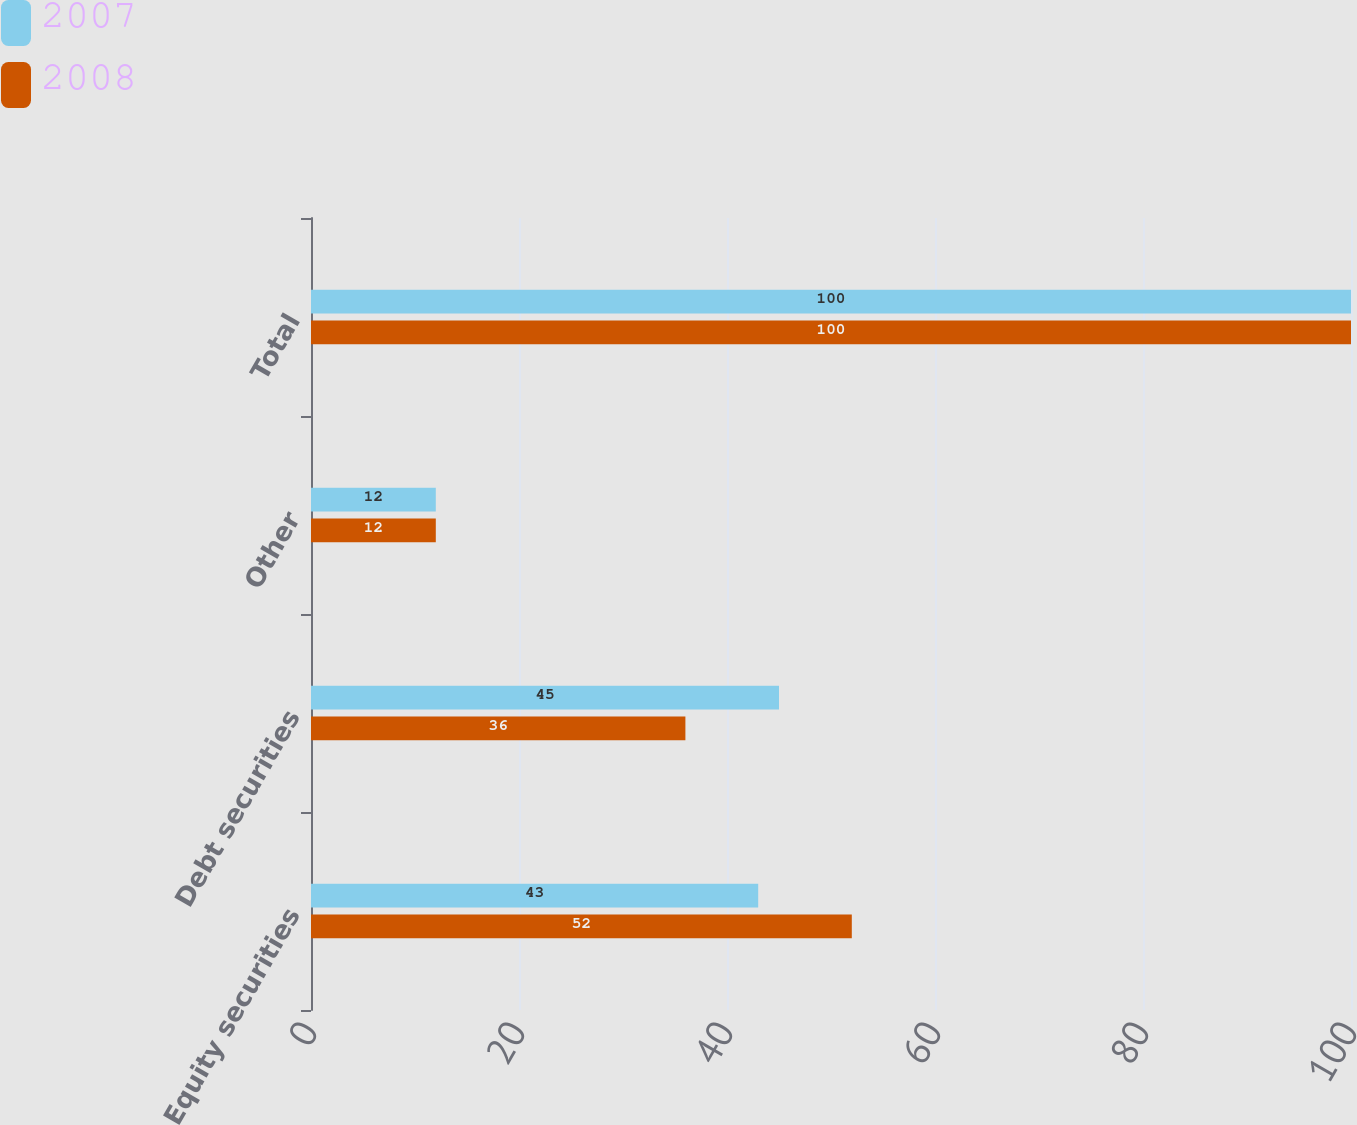<chart> <loc_0><loc_0><loc_500><loc_500><stacked_bar_chart><ecel><fcel>Equity securities<fcel>Debt securities<fcel>Other<fcel>Total<nl><fcel>2007<fcel>43<fcel>45<fcel>12<fcel>100<nl><fcel>2008<fcel>52<fcel>36<fcel>12<fcel>100<nl></chart> 